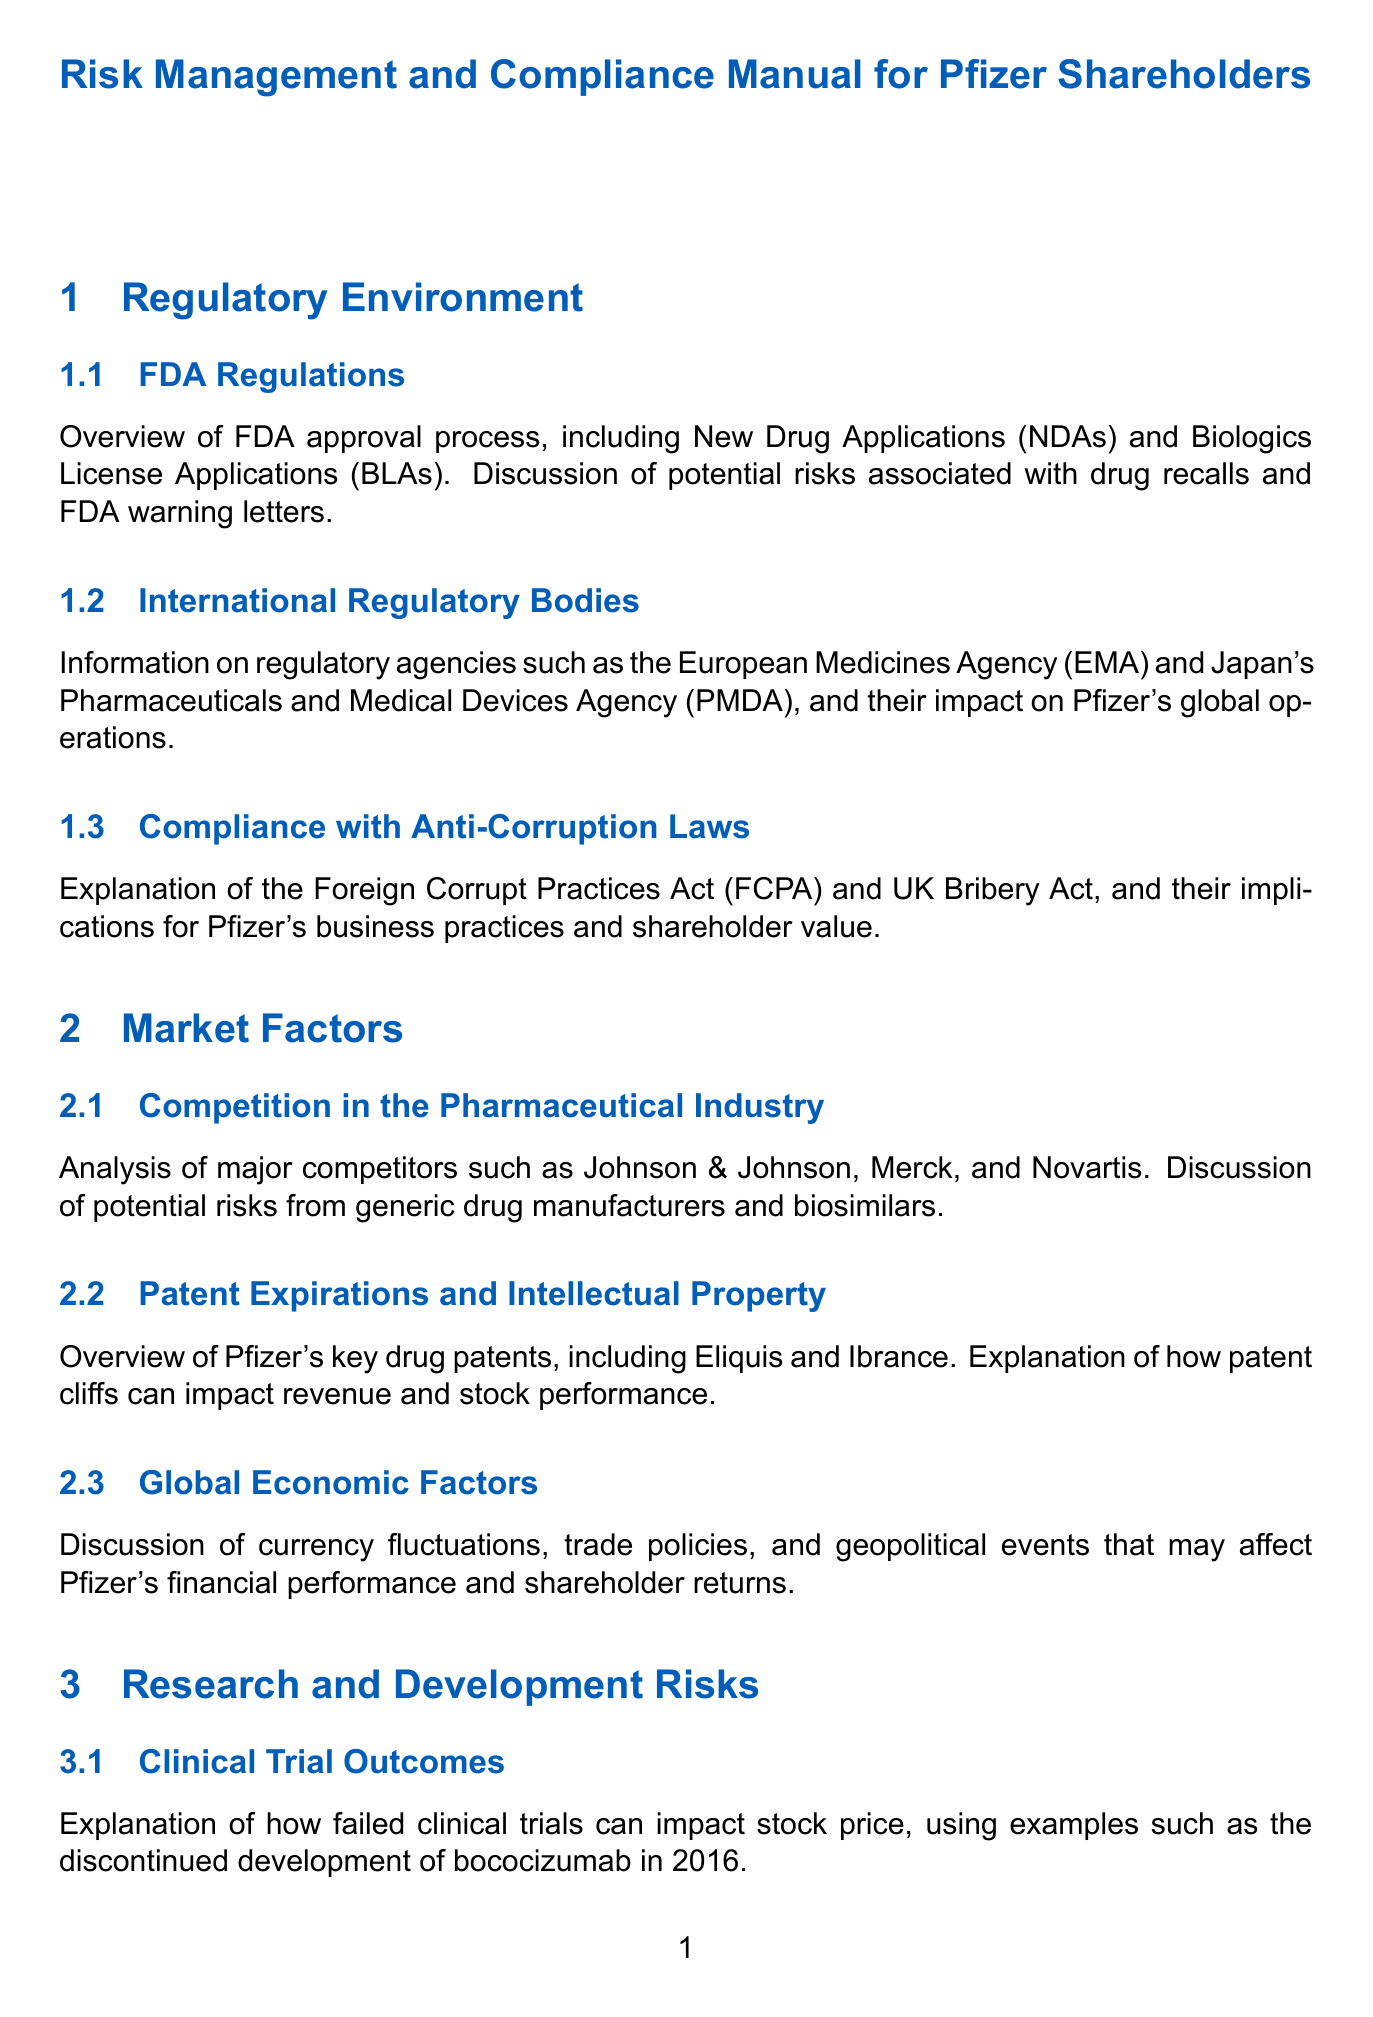What is the title of the manual? The title states the purpose and audience of the document, which is "Risk Management and Compliance Manual for Pfizer Shareholders."
Answer: Risk Management and Compliance Manual for Pfizer Shareholders What regulatory body approves New Drug Applications? The subsection discusses the approval process for drugs, specifically mentioning the FDA as the authority for NDAs.
Answer: FDA Who is a major competitor of Pfizer mentioned in the document? The section on competition identifies several competitors, one of which is Johnson & Johnson.
Answer: Johnson & Johnson What type of act is the Foreign Corrupt Practices Act? This act is related to compliance and anti-corruption, impacting Pfizer's business practices.
Answer: Anti-Corruption How does a failed clinical trial affect Pfizer's financials? The document explains that failed trials can lead to stock price impacts, exemplifying this with a past drug development failure.
Answer: Stock price What is a key aspect of Pfizer’s market factors regarding patents? The discussion emphasizes the impact of patent expirations on revenues, particularly focusing on drugs like Eliquis.
Answer: Patent expirations What does ESG stand for in the context of the document? This acronym is associated with Environmental, Social, and Governance factors relevant to Pfizer’s initiatives.
Answer: ESG What is the significance of supply chain management risks for Pfizer? The document highlights supply chain management as a critical aspect due to external events that can disrupt operations.
Answer: Critical aspect What information is provided for shareholders about monitoring risks? The manual advises on accessing Pfizer's annual reports and SEC filings for ongoing assessment.
Answer: Annual reports and SEC filings 